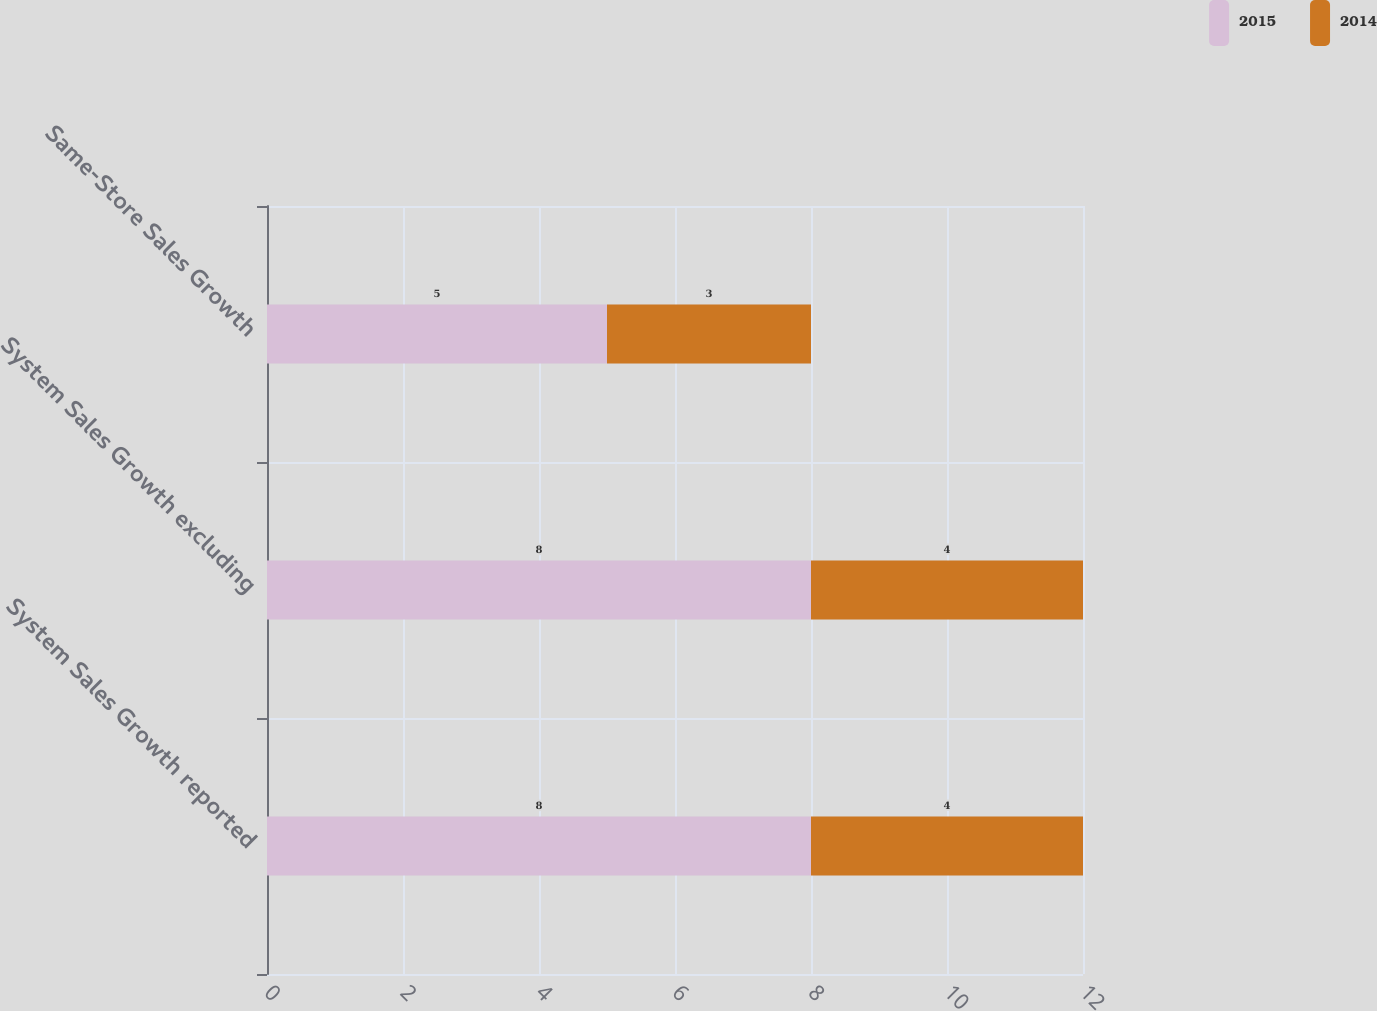<chart> <loc_0><loc_0><loc_500><loc_500><stacked_bar_chart><ecel><fcel>System Sales Growth reported<fcel>System Sales Growth excluding<fcel>Same-Store Sales Growth<nl><fcel>2015<fcel>8<fcel>8<fcel>5<nl><fcel>2014<fcel>4<fcel>4<fcel>3<nl></chart> 